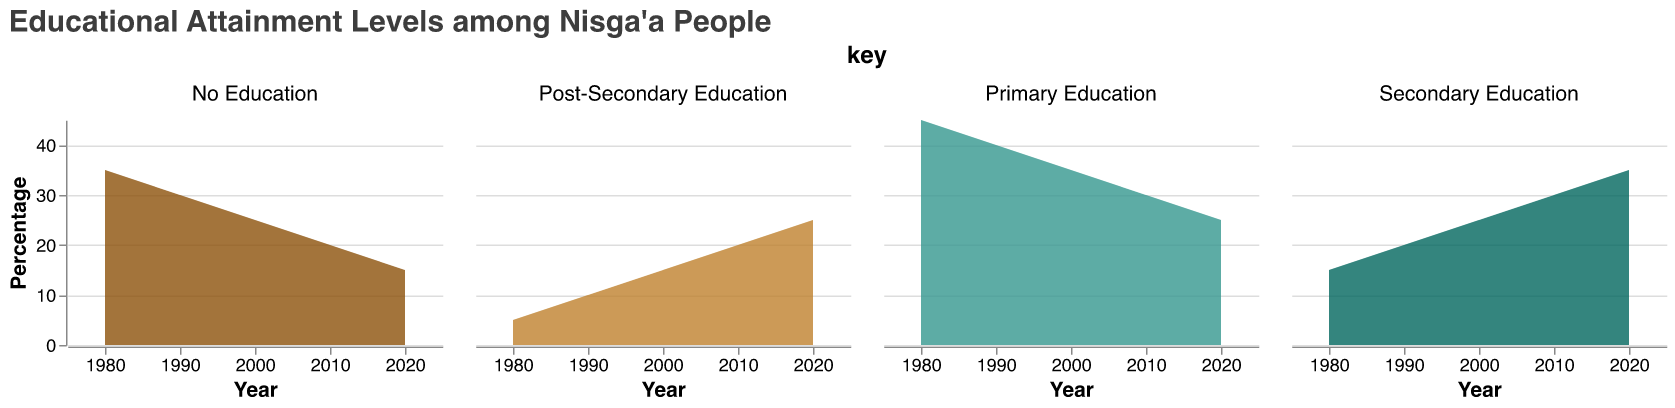What is the title of the chart? The title of the chart is at the top and typically describes the content or the scope of the chart. Here, it states "Educational Attainment Levels among Nisga'a People".
Answer: Educational Attainment Levels among Nisga'a People Which educational attainment level had the highest percentage in 1980? By examining the points in 1980 across the multiple subplots, you can see that the highest percentage in 1980 is for Primary Education.
Answer: Primary Education How did the percentage of Nisga’a people with no education change from 1980 to 2020? Observing the No Education subplot, in 1980, the percentage was 35%, and this dropped to 15% by 2020. Calculating the difference, 35% - 15% = 20%.
Answer: It decreased by 20% What was the percentage of Nisga’a people with post-secondary education in 2000? In the Post-Secondary Education subplot, find the value corresponding to the year 2000. This value is 15%.
Answer: 15% What educational attainment level shows the largest increase in percentage from 1980 to 2020? Comparing all subplots, look at the values from 1980 and 2020. Secondary Education goes from 15% in 1980 to 35% in 2020, an increase of 20%, which is the largest among all levels.
Answer: Secondary Education Compare the percentage of Nisga’a people with primary education in 1990 and 2020. Which year had a higher percentage? In the Primary Education subplot, the value in 1990 is 40% and in 2020 it is 25%. Comparing these, 1990 had the higher percentage.
Answer: 1990 Which educational attainment level had the lowest percentage in 2010? Observing the values for 2010 in each subplot, the Post-Secondary Education level had 20%, which is the lowest among all levels for that year.
Answer: Post-Secondary Education What is the trend of secondary education attainment from 1980 to 2020? Watching the trend line in the Secondary Education subplot, it consistently increases from 15% in 1980 to 35% in 2020.
Answer: Increasing In which decade did the percentage of Nisga’a people with no education decrease the most? Observing the No Education subplot, the largest drop occurs between 1980 (35%) and 1990 (30%), which is a decrease of 5%. This is the largest drop compared to other decades.
Answer: Between 1980 and 1990 